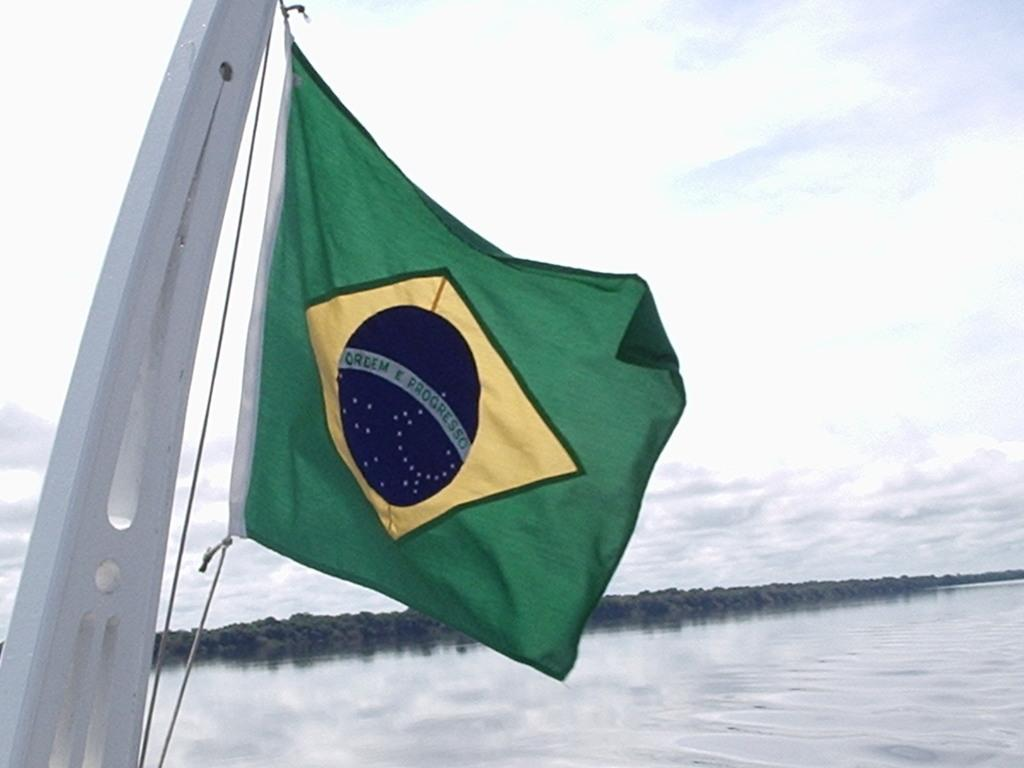What is the tall, vertical object in the image? There is a pole in the image. What is attached to the pole? A flag is present on the pole. What can be seen in the distance in the image? There is water and trees visible in the background of the image. How would you describe the weather in the image? The sky is cloudy in the image. What type of yam is being used to hold the flag in the image? There is no yam present in the image. The flag is attached to the pole, not a yam. 